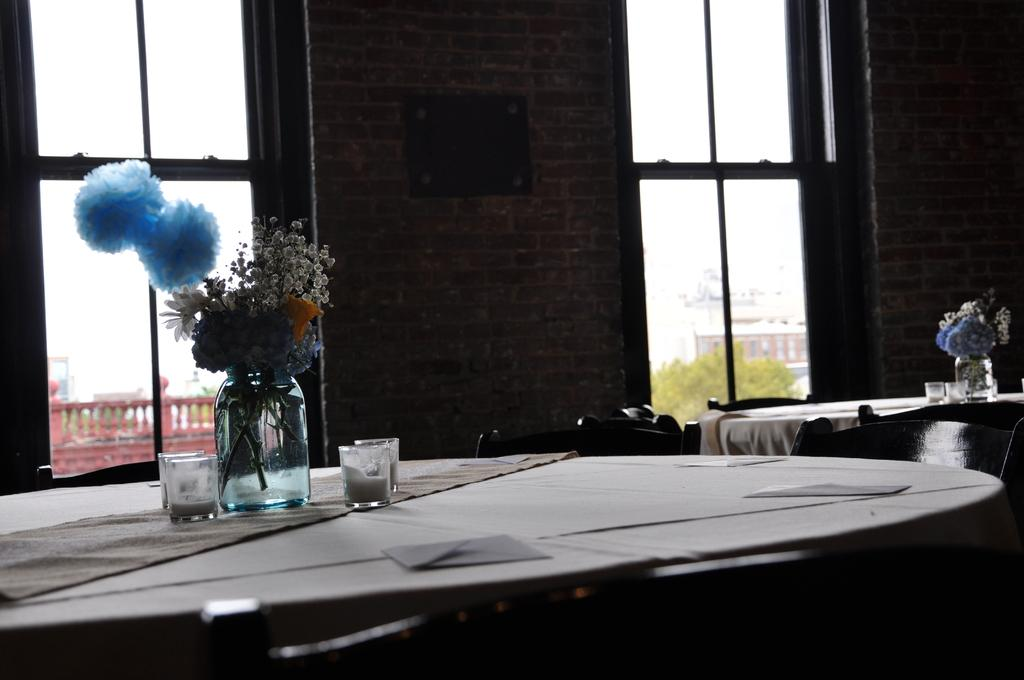How many dining tables are visible in the image? There are two empty dining tables in the image. What is placed on the tables? There are flower vases and candles on the tables. What can be seen in the background of the image? There are two windows and a brick wall between the windows in the background of the image. What type of liquid is being used to polish the tables in the image? There is no liquid or polishing activity visible in the image; the tables are empty. 